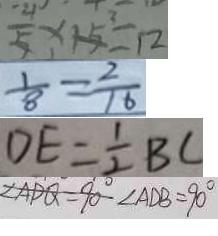Convert formula to latex. <formula><loc_0><loc_0><loc_500><loc_500>\frac { 4 } { 5 } \times 1 5 = 1 2 
 \frac { 1 } { 8 } = \frac { 2 } { 1 6 } 
 D E = \frac { 1 } { 2 } B C 
 \angle A D Q = 9 0 ^ { \circ } \angle A D B = 9 0 ^ { \circ }</formula> 